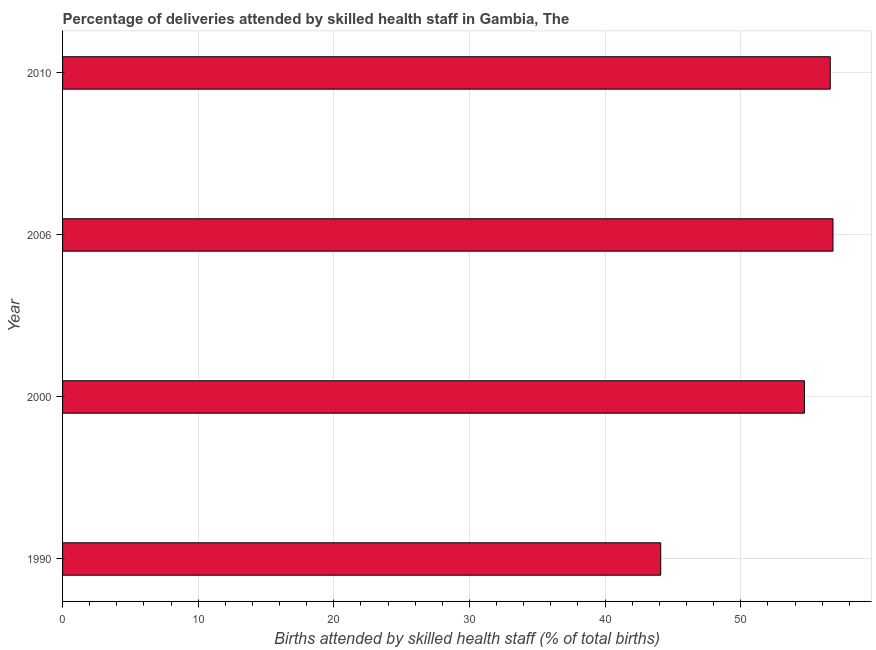Does the graph contain any zero values?
Ensure brevity in your answer.  No. What is the title of the graph?
Provide a succinct answer. Percentage of deliveries attended by skilled health staff in Gambia, The. What is the label or title of the X-axis?
Offer a terse response. Births attended by skilled health staff (% of total births). What is the label or title of the Y-axis?
Offer a terse response. Year. What is the number of births attended by skilled health staff in 1990?
Offer a terse response. 44.1. Across all years, what is the maximum number of births attended by skilled health staff?
Your response must be concise. 56.8. Across all years, what is the minimum number of births attended by skilled health staff?
Provide a succinct answer. 44.1. What is the sum of the number of births attended by skilled health staff?
Offer a terse response. 212.2. What is the difference between the number of births attended by skilled health staff in 2000 and 2006?
Your answer should be compact. -2.1. What is the average number of births attended by skilled health staff per year?
Offer a very short reply. 53.05. What is the median number of births attended by skilled health staff?
Your answer should be compact. 55.65. In how many years, is the number of births attended by skilled health staff greater than 34 %?
Provide a succinct answer. 4. What is the ratio of the number of births attended by skilled health staff in 1990 to that in 2000?
Provide a succinct answer. 0.81. What is the difference between the highest and the second highest number of births attended by skilled health staff?
Offer a very short reply. 0.2. Are the values on the major ticks of X-axis written in scientific E-notation?
Make the answer very short. No. What is the Births attended by skilled health staff (% of total births) of 1990?
Your answer should be very brief. 44.1. What is the Births attended by skilled health staff (% of total births) in 2000?
Keep it short and to the point. 54.7. What is the Births attended by skilled health staff (% of total births) in 2006?
Ensure brevity in your answer.  56.8. What is the Births attended by skilled health staff (% of total births) in 2010?
Your answer should be compact. 56.6. What is the difference between the Births attended by skilled health staff (% of total births) in 1990 and 2010?
Your answer should be very brief. -12.5. What is the difference between the Births attended by skilled health staff (% of total births) in 2000 and 2010?
Ensure brevity in your answer.  -1.9. What is the ratio of the Births attended by skilled health staff (% of total births) in 1990 to that in 2000?
Ensure brevity in your answer.  0.81. What is the ratio of the Births attended by skilled health staff (% of total births) in 1990 to that in 2006?
Make the answer very short. 0.78. What is the ratio of the Births attended by skilled health staff (% of total births) in 1990 to that in 2010?
Your answer should be compact. 0.78. What is the ratio of the Births attended by skilled health staff (% of total births) in 2000 to that in 2006?
Offer a terse response. 0.96. What is the ratio of the Births attended by skilled health staff (% of total births) in 2000 to that in 2010?
Ensure brevity in your answer.  0.97. 